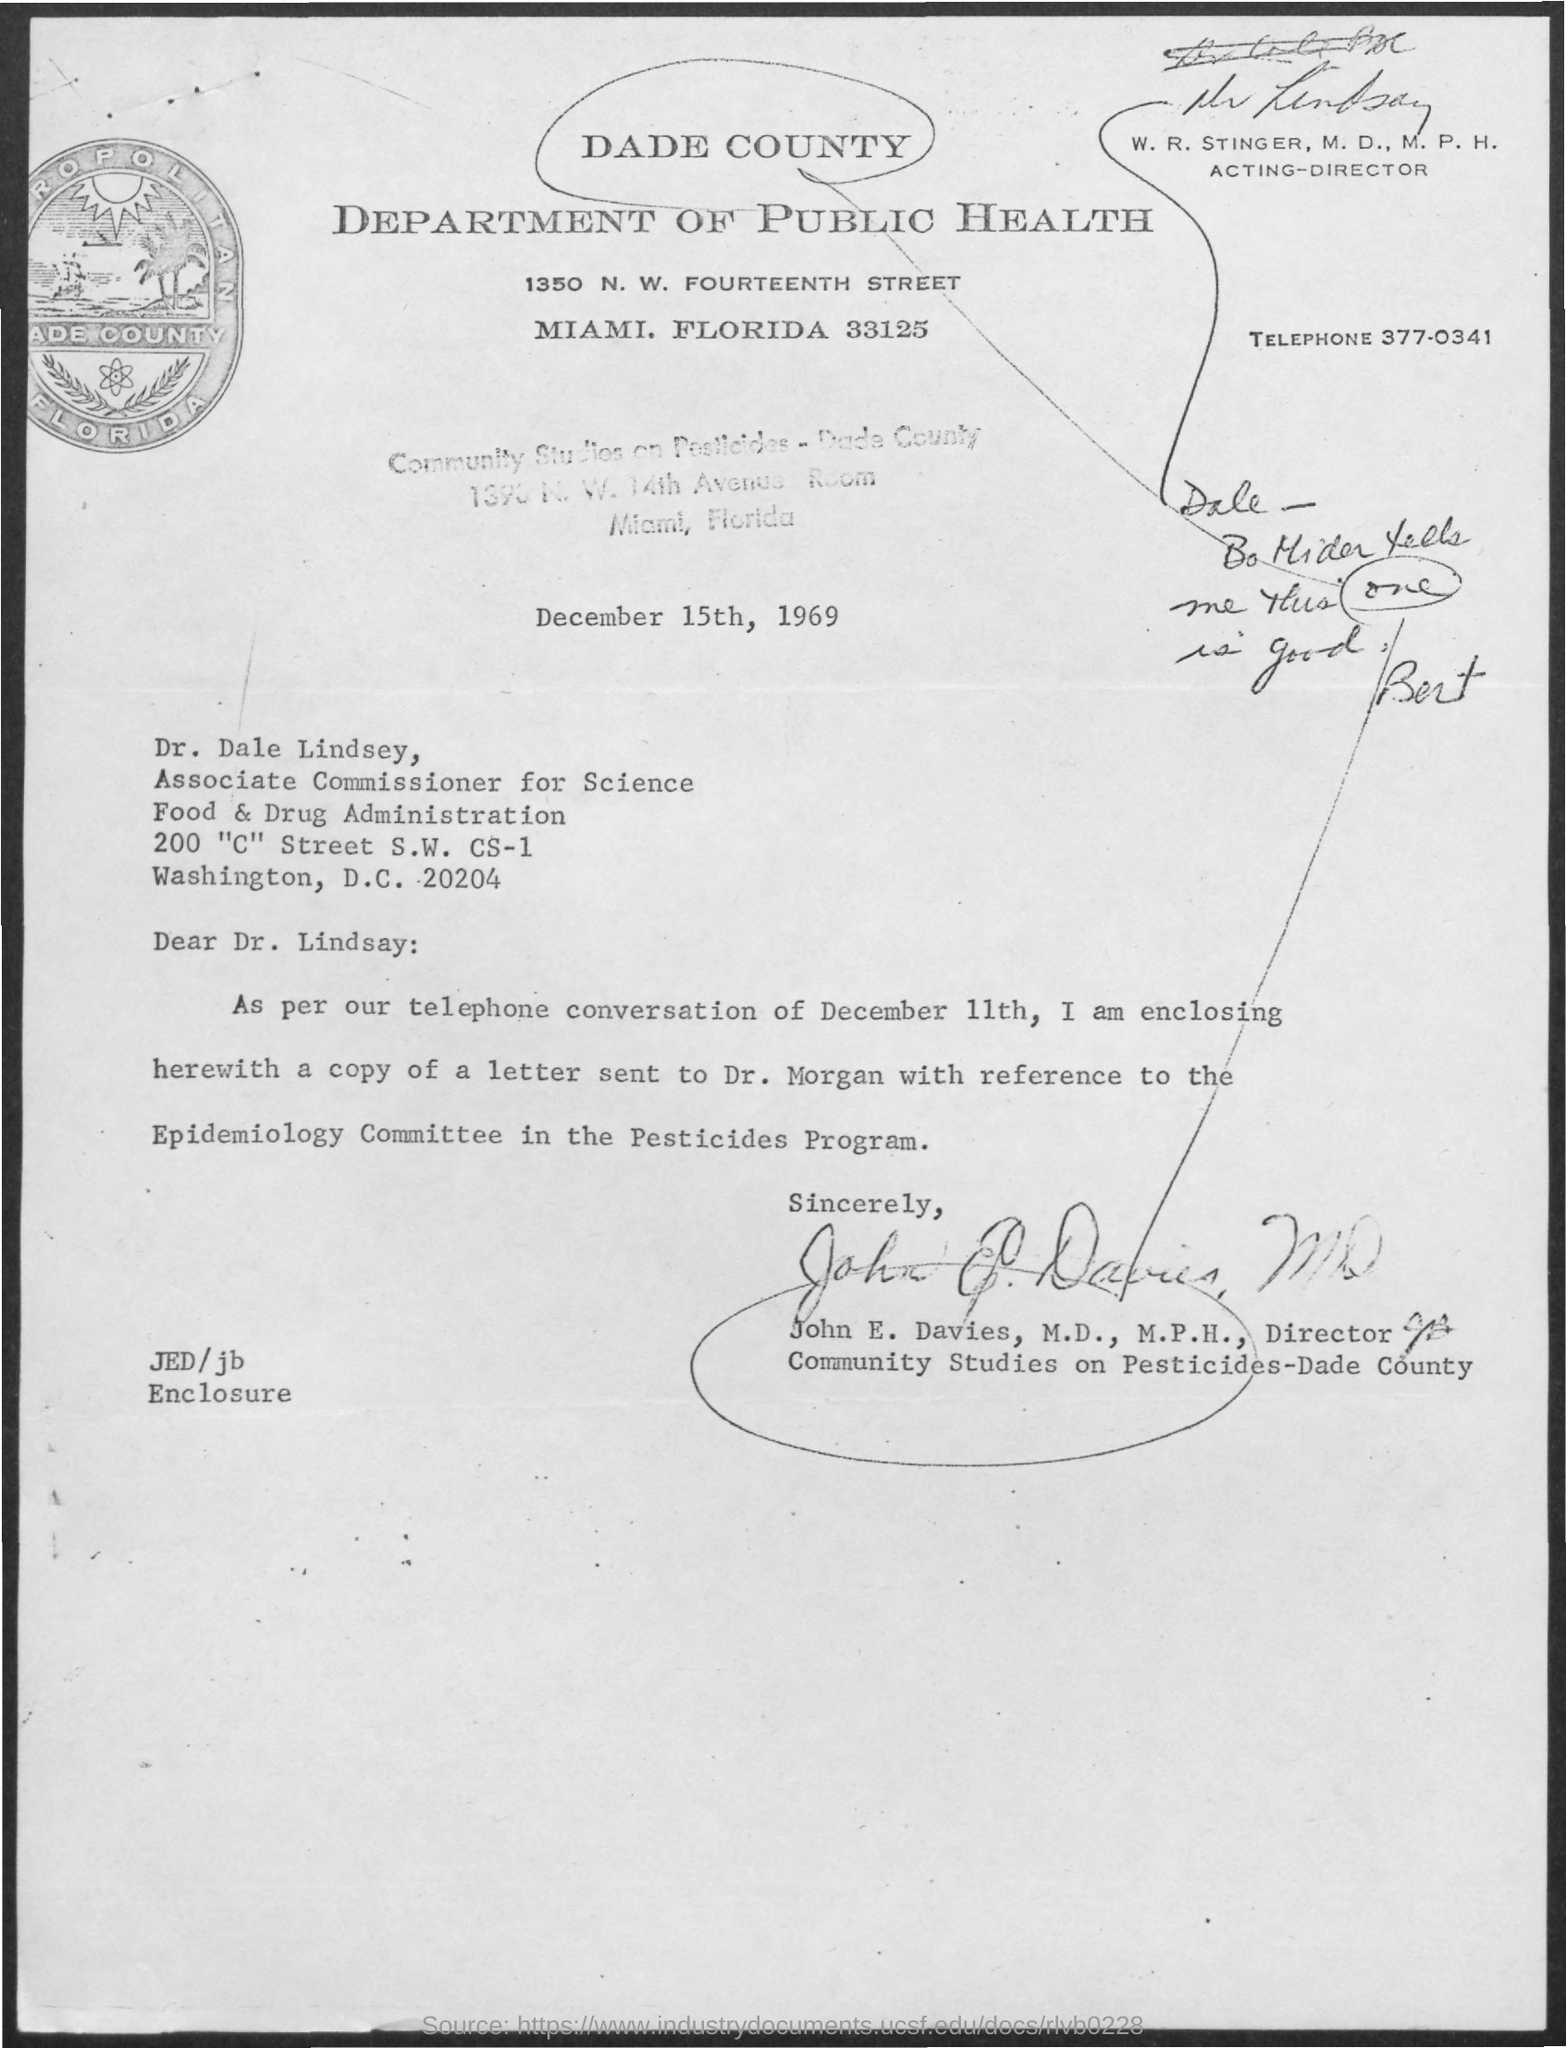Outline some significant characteristics in this image. The telephone number mentioned in the given letter is 377-0341. The given letter mentions a department called "Department of Public Health. The date mentioned in the given letter is December 15th, 1969. The given letter mentions a person named W.R. Stinger with the designation of Acting-Director. Dr. Dale Lindsey is designated as Associate Commissioner for Science in the given letter. 